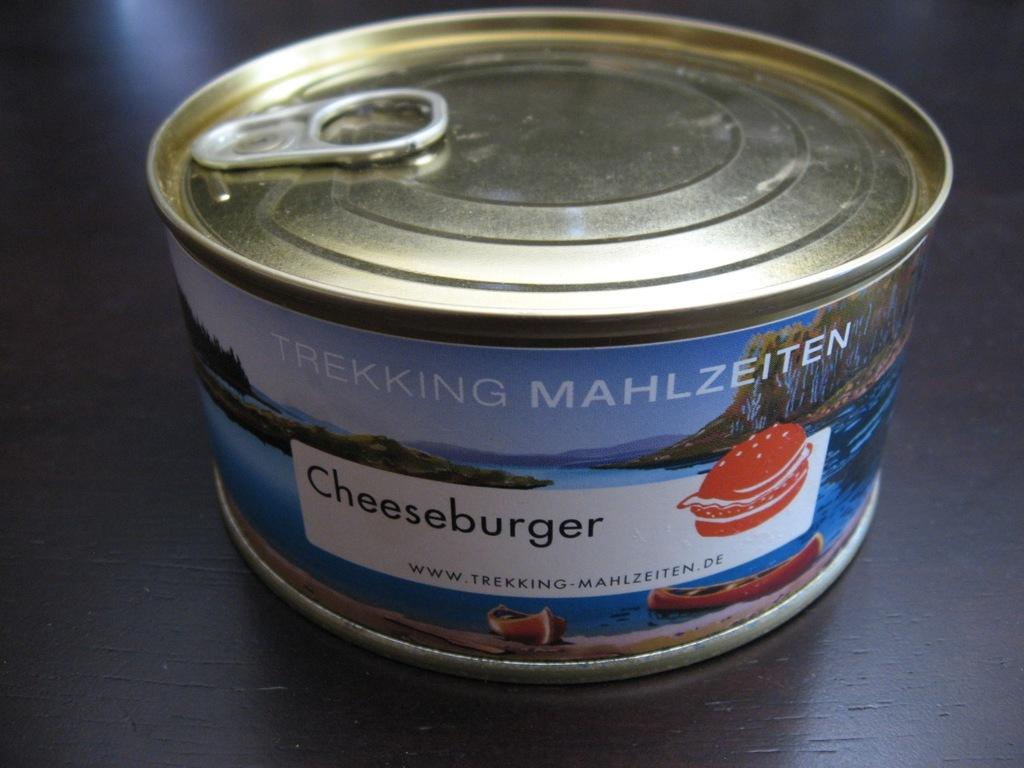<image>
Offer a succinct explanation of the picture presented. a small can  that is labeled 'cheeseburger' 